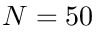Convert formula to latex. <formula><loc_0><loc_0><loc_500><loc_500>N = 5 0</formula> 